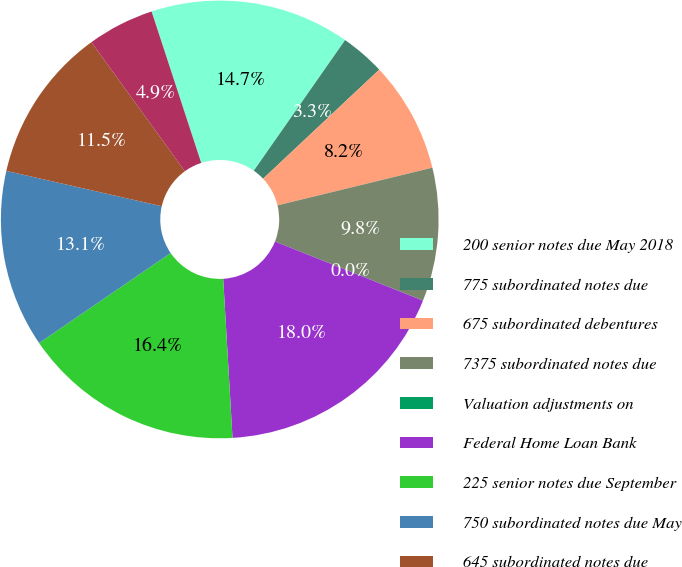Convert chart to OTSL. <chart><loc_0><loc_0><loc_500><loc_500><pie_chart><fcel>200 senior notes due May 2018<fcel>775 subordinated notes due<fcel>675 subordinated debentures<fcel>7375 subordinated notes due<fcel>Valuation adjustments on<fcel>Federal Home Loan Bank<fcel>225 senior notes due September<fcel>750 subordinated notes due May<fcel>645 subordinated notes due<fcel>380 affiliate subordinated<nl><fcel>14.75%<fcel>3.29%<fcel>8.2%<fcel>9.84%<fcel>0.01%<fcel>18.02%<fcel>16.38%<fcel>13.11%<fcel>11.47%<fcel>4.93%<nl></chart> 